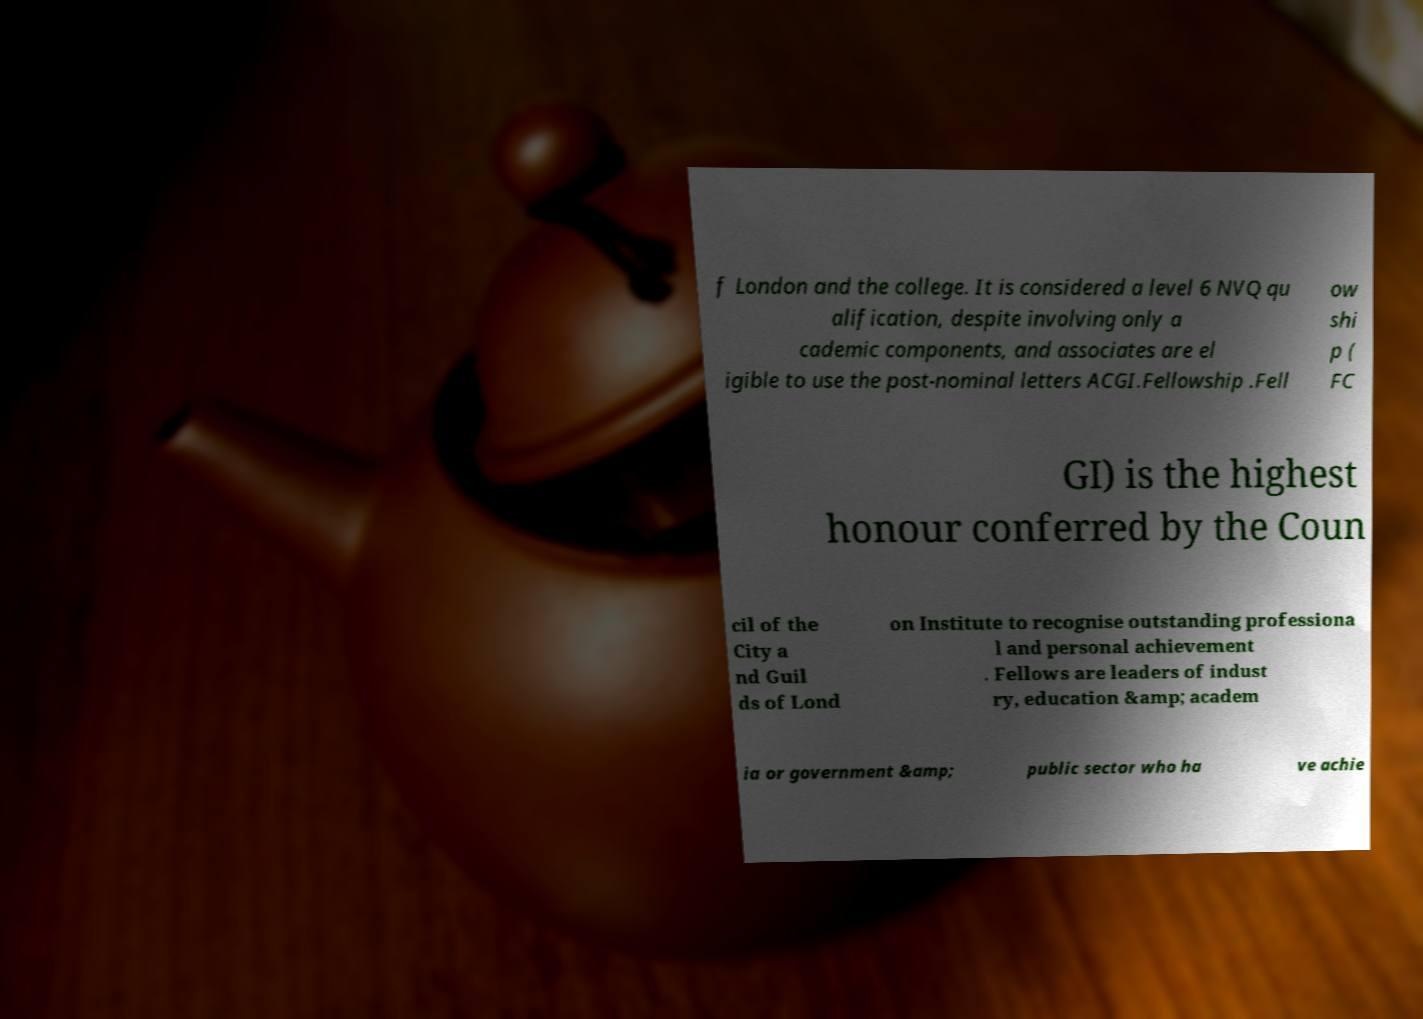I need the written content from this picture converted into text. Can you do that? f London and the college. It is considered a level 6 NVQ qu alification, despite involving only a cademic components, and associates are el igible to use the post-nominal letters ACGI.Fellowship .Fell ow shi p ( FC GI) is the highest honour conferred by the Coun cil of the City a nd Guil ds of Lond on Institute to recognise outstanding professiona l and personal achievement . Fellows are leaders of indust ry, education &amp; academ ia or government &amp; public sector who ha ve achie 